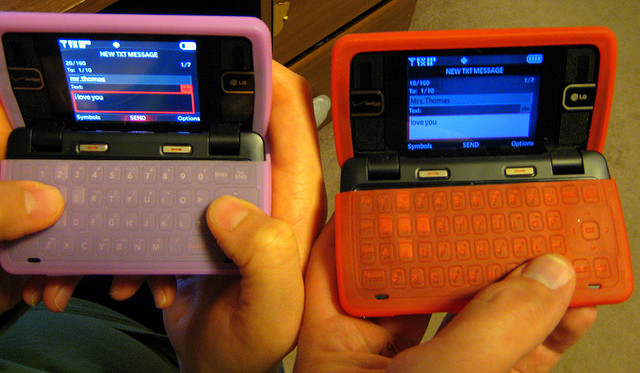Extract all visible text content from this image. TXT MESSAGE 20 Symbals Options SEND you ICO MESSAGE 